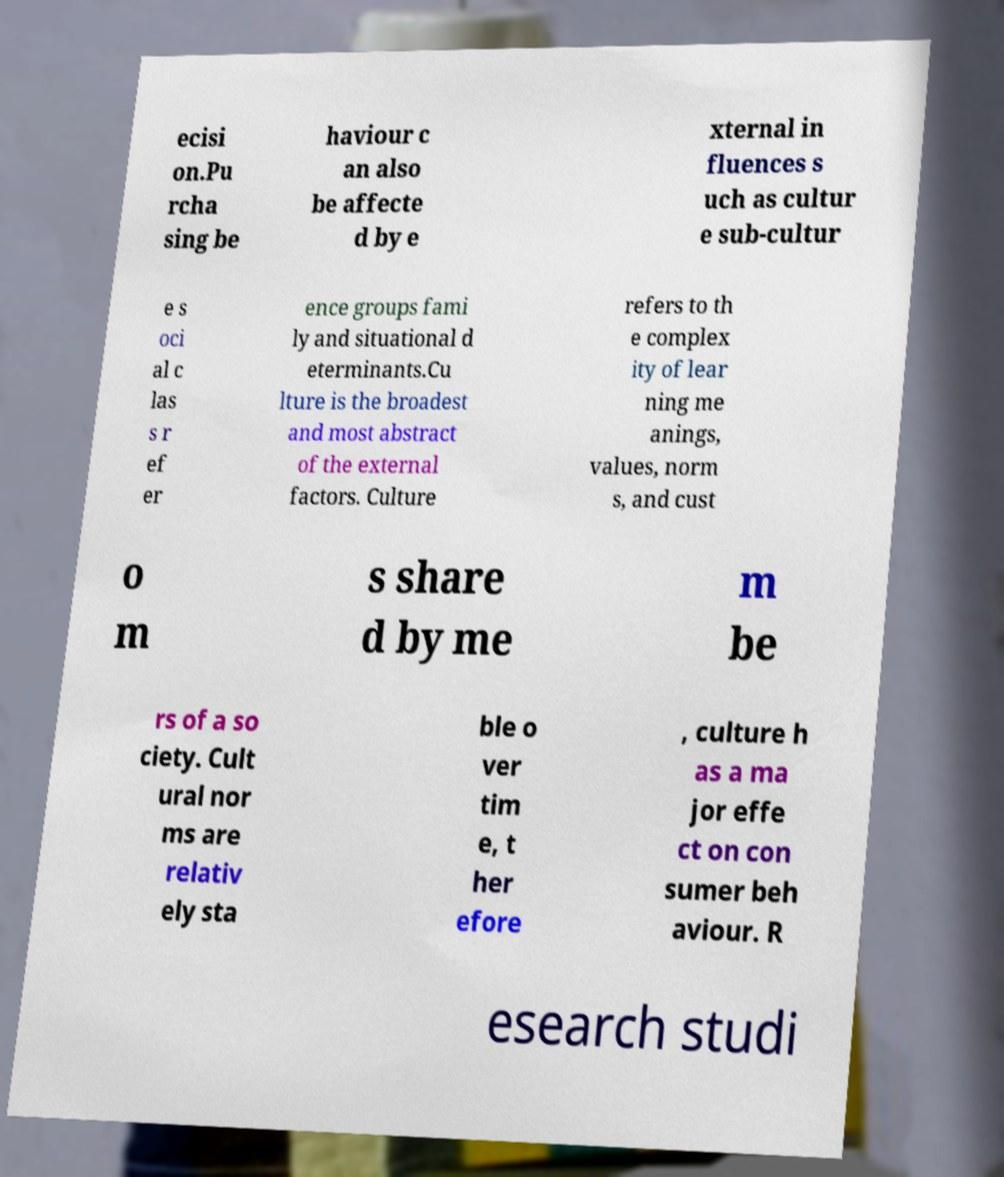Please read and relay the text visible in this image. What does it say? ecisi on.Pu rcha sing be haviour c an also be affecte d by e xternal in fluences s uch as cultur e sub-cultur e s oci al c las s r ef er ence groups fami ly and situational d eterminants.Cu lture is the broadest and most abstract of the external factors. Culture refers to th e complex ity of lear ning me anings, values, norm s, and cust o m s share d by me m be rs of a so ciety. Cult ural nor ms are relativ ely sta ble o ver tim e, t her efore , culture h as a ma jor effe ct on con sumer beh aviour. R esearch studi 